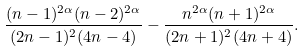Convert formula to latex. <formula><loc_0><loc_0><loc_500><loc_500>\frac { ( n - 1 ) ^ { 2 \alpha } ( n - 2 ) ^ { 2 \alpha } } { ( 2 n - 1 ) ^ { 2 } ( 4 n - 4 ) } - \frac { n ^ { 2 \alpha } ( n + 1 ) ^ { 2 \alpha } } { ( 2 n + 1 ) ^ { 2 } ( 4 n + 4 ) } .</formula> 